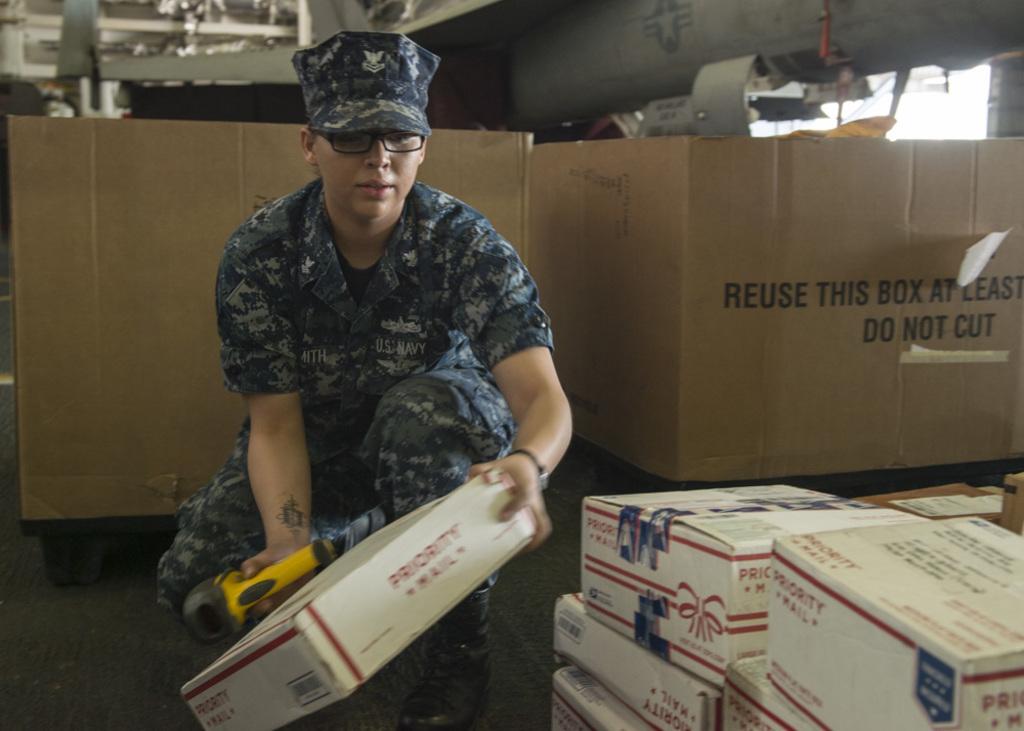What type of mail is it?
Keep it short and to the point. Priority. What does the brown box instruct you to do?
Your response must be concise. Do not cut. 